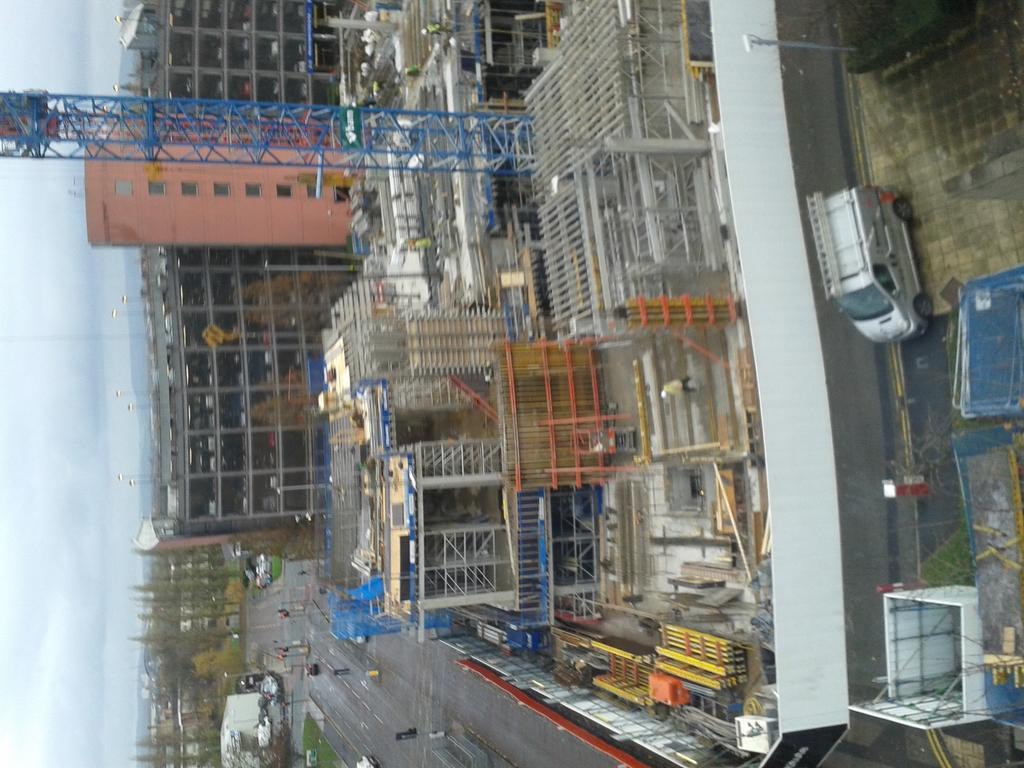How would you summarize this image in a sentence or two? In this image we can see buildings, road, vehicles, poles, traffic signals, sky and clouds. 